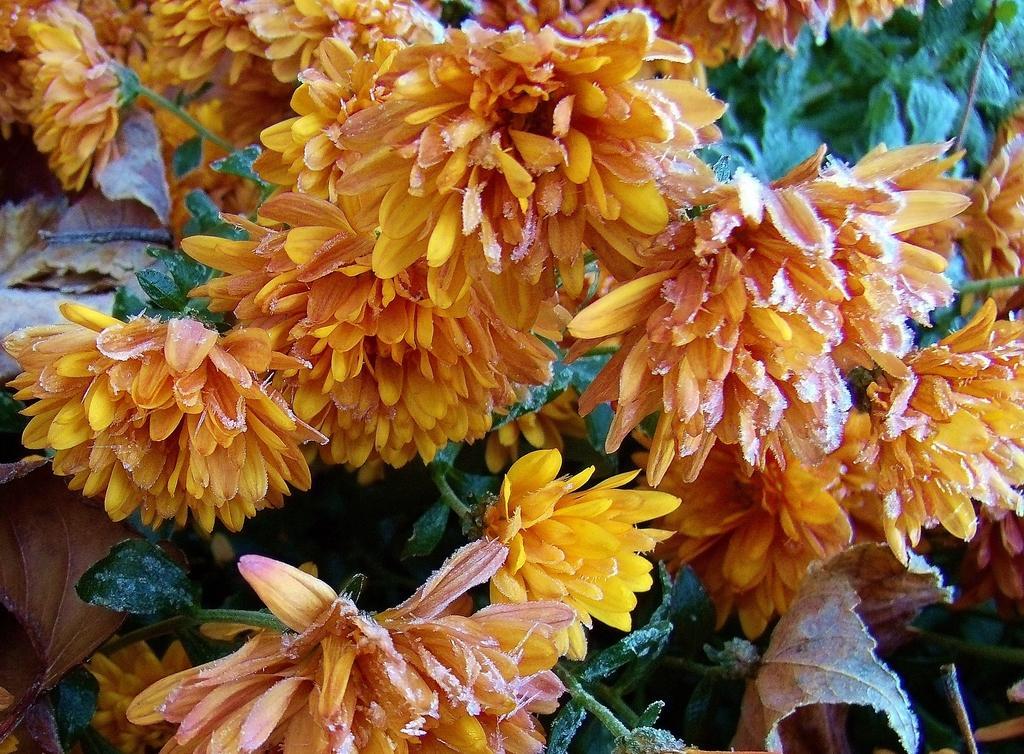Can you describe this image briefly? In this picture we can observe yellow color flowers to the plants. In the background we can observe green color plants. 